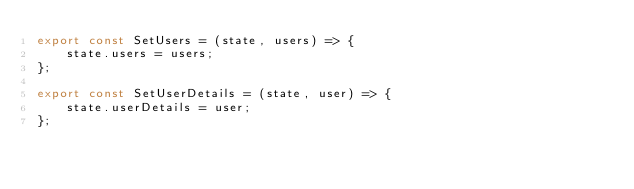Convert code to text. <code><loc_0><loc_0><loc_500><loc_500><_JavaScript_>export const SetUsers = (state, users) => {
    state.users = users;
};

export const SetUserDetails = (state, user) => {
    state.userDetails = user;
};</code> 